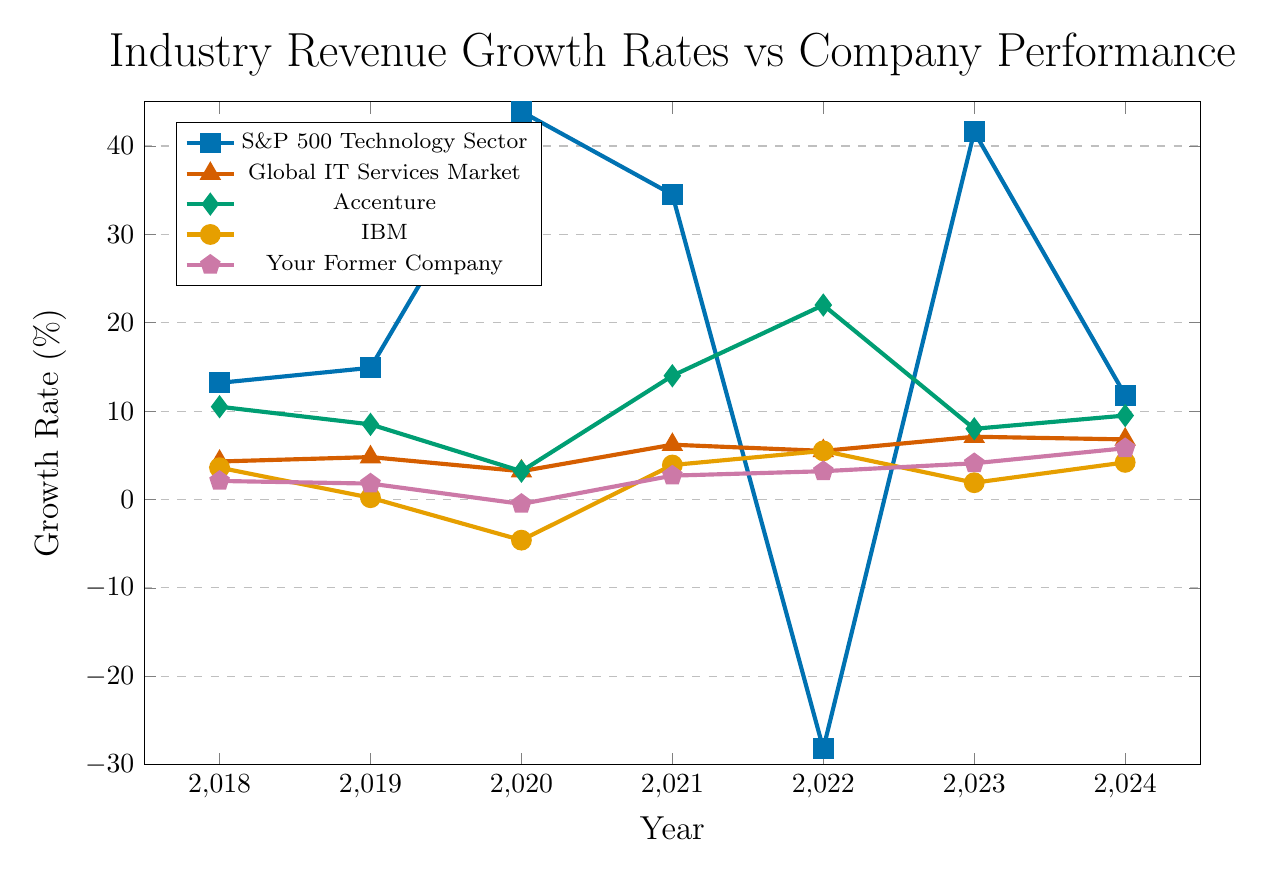What is the growth rate for the S&P 500 Technology Sector in 2023? Locate the data corresponding to the S&P 500 Technology Sector's growth rate for the year 2023 on the line chart.
Answer: 41.6% How does the growth rate of your former company in 2024 compare to Accenture's in the same year? Compare the data points for your former company and Accenture for the year 2024. Your former company's growth rate is 5.8%, and Accenture's is 9.5%. 5.8% is lower than 9.5%.
Answer: 5.8% is less than 9.5% By how much did your former company's growth rate change from 2020 to 2021? Subtract the growth rate of your former company in 2020 (-0.5%) from its growth rate in 2021 (2.7%). The calculation is 2.7% - (-0.5%) = 2.7% + 0.5% = 3.2%.
Answer: 3.2% What was the average growth rate of the Global IT Services Market from 2021 to 2023? Find the growth rates of the Global IT Services Market for the years 2021, 2022, and 2023: 6.2%, 5.5%, and 7.1%. Compute the average as (6.2% + 5.5% + 7.1%) / 3 = 6.27%.
Answer: 6.27% Which year did IBM experience its lowest growth rate? Identify the lowest point in IBM's growth rate data across all the years. IBM had its lowest growth rate in 2020 with -4.6%.
Answer: 2020 Compare the trend in growth rate between the S&P 500 Technology Sector and your former company from 2018 to 2022. Observe the trend lines for the S&P 500 Technology Sector and your former company from 2018 to 2022. The S&P 500 Technology Sector experienced significant fluctuations and turned negative in 2022, whereas your former company shows a generally increasing trend with no negative values from 2021 onwards.
Answer: S&P 500 Technology Sector fluctuates greatly, your former company shows overall growth What is the difference in growth rate between the S&P 500 Technology Sector and the Global IT Services Market in 2022? Subtract the Global IT Services Market growth rate (5.5%) from the S&P 500 Technology Sector's growth rate (-28.2%) in 2022. The difference is -28.2% - 5.5% = -33.7%.
Answer: -33.7% What was your former company's growth rate in 2021 and how did it compare to IBM's that year? Locate the growth rates for your former company (2.7%) and IBM (3.9%) in 2021. Your former company’s growth rate was 2.7%, which is less than IBM’s 3.9%.
Answer: 2.7% is less than 3.9% How did the growth rate for Accenture change between 2020 and 2022? Find Accenture's growth rate in 2020 (3.2%) and in 2022 (22.0%). Calculate the change by subtracting 3.2% from 22.0%, resulting in 22.0% - 3.2% = 18.8%.
Answer: 18.8% 